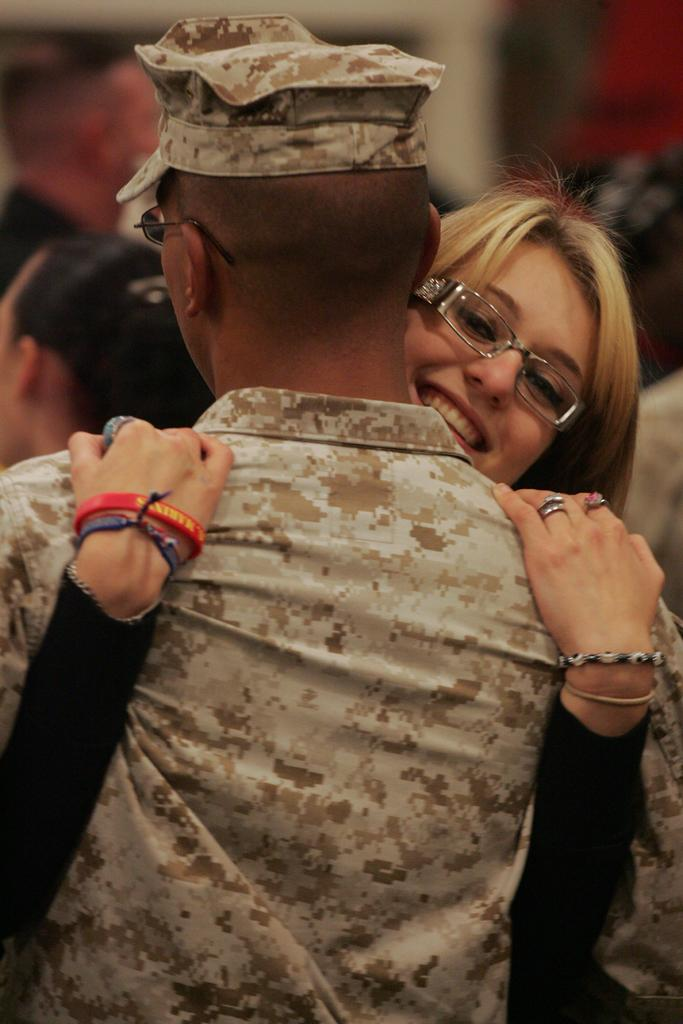What is the main subject of the image? The main subject of the image is a group of people. Can you describe the background of the image? The background of the image is blurry. What type of space suit is the person wearing in the image? There is no person wearing a space suit in the image, as it features a group of people without any visible space suits. What is the person holding in their hand in the image? There is no person holding a mitten or oatmeal in the image, as it only features a group of people without any visible objects in their hands. 